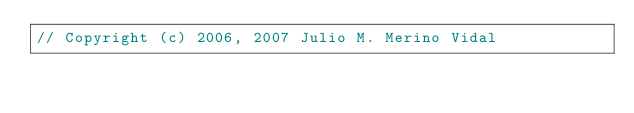<code> <loc_0><loc_0><loc_500><loc_500><_C++_>// Copyright (c) 2006, 2007 Julio M. Merino Vidal</code> 